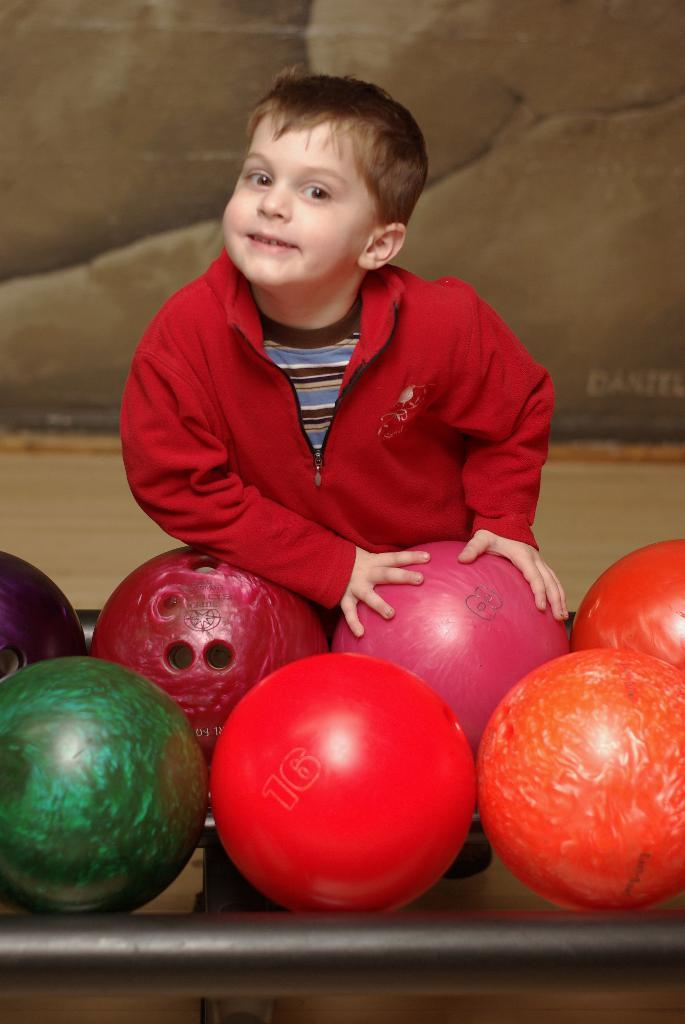What is the main subject of the image? There is a boy in the center of the image. What is the boy doing in the image? The boy is standing and smiling. What objects are present near the boy? There are bowling balls placed on a table in front of the boy. What type of pest can be seen crawling on the boy's shoulder in the image? There is no pest visible on the boy's shoulder in the image. How does the taste of the bowling balls compare to that of a bee? The taste of the bowling balls cannot be compared to that of a bee, as bowling balls are not edible and bees are not typically associated with taste. 